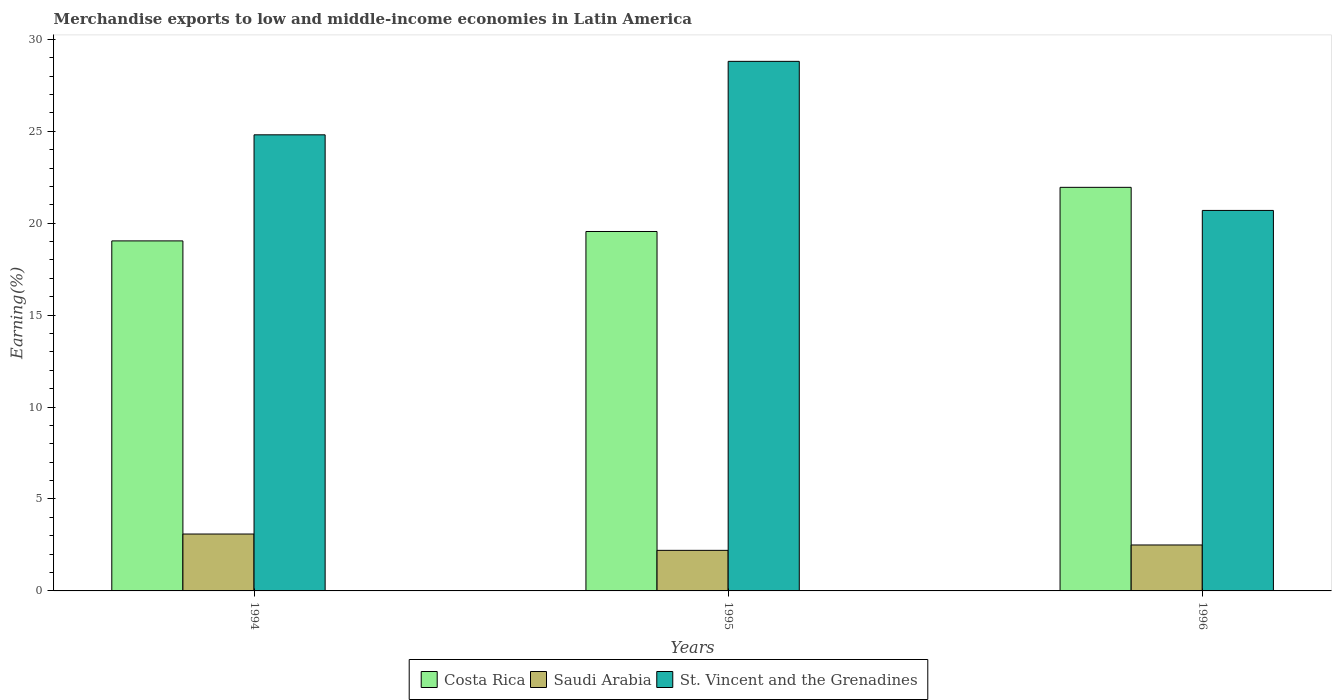How many different coloured bars are there?
Offer a terse response. 3. How many groups of bars are there?
Your answer should be very brief. 3. Are the number of bars on each tick of the X-axis equal?
Make the answer very short. Yes. How many bars are there on the 3rd tick from the left?
Your response must be concise. 3. How many bars are there on the 2nd tick from the right?
Provide a succinct answer. 3. What is the label of the 1st group of bars from the left?
Ensure brevity in your answer.  1994. What is the percentage of amount earned from merchandise exports in Saudi Arabia in 1994?
Offer a terse response. 3.09. Across all years, what is the maximum percentage of amount earned from merchandise exports in Costa Rica?
Offer a terse response. 21.95. Across all years, what is the minimum percentage of amount earned from merchandise exports in Saudi Arabia?
Provide a short and direct response. 2.21. In which year was the percentage of amount earned from merchandise exports in St. Vincent and the Grenadines maximum?
Provide a short and direct response. 1995. What is the total percentage of amount earned from merchandise exports in St. Vincent and the Grenadines in the graph?
Ensure brevity in your answer.  74.3. What is the difference between the percentage of amount earned from merchandise exports in St. Vincent and the Grenadines in 1995 and that in 1996?
Your answer should be compact. 8.11. What is the difference between the percentage of amount earned from merchandise exports in St. Vincent and the Grenadines in 1996 and the percentage of amount earned from merchandise exports in Costa Rica in 1995?
Make the answer very short. 1.15. What is the average percentage of amount earned from merchandise exports in Costa Rica per year?
Offer a very short reply. 20.18. In the year 1996, what is the difference between the percentage of amount earned from merchandise exports in Costa Rica and percentage of amount earned from merchandise exports in Saudi Arabia?
Ensure brevity in your answer.  19.45. In how many years, is the percentage of amount earned from merchandise exports in Saudi Arabia greater than 18 %?
Offer a very short reply. 0. What is the ratio of the percentage of amount earned from merchandise exports in Saudi Arabia in 1994 to that in 1996?
Offer a terse response. 1.24. Is the difference between the percentage of amount earned from merchandise exports in Costa Rica in 1995 and 1996 greater than the difference between the percentage of amount earned from merchandise exports in Saudi Arabia in 1995 and 1996?
Give a very brief answer. No. What is the difference between the highest and the second highest percentage of amount earned from merchandise exports in St. Vincent and the Grenadines?
Your response must be concise. 4. What is the difference between the highest and the lowest percentage of amount earned from merchandise exports in Costa Rica?
Provide a short and direct response. 2.91. Is the sum of the percentage of amount earned from merchandise exports in Saudi Arabia in 1994 and 1996 greater than the maximum percentage of amount earned from merchandise exports in Costa Rica across all years?
Make the answer very short. No. What does the 1st bar from the left in 1994 represents?
Provide a short and direct response. Costa Rica. Does the graph contain grids?
Provide a succinct answer. No. Where does the legend appear in the graph?
Your response must be concise. Bottom center. How many legend labels are there?
Your response must be concise. 3. How are the legend labels stacked?
Ensure brevity in your answer.  Horizontal. What is the title of the graph?
Your answer should be compact. Merchandise exports to low and middle-income economies in Latin America. What is the label or title of the X-axis?
Your answer should be very brief. Years. What is the label or title of the Y-axis?
Keep it short and to the point. Earning(%). What is the Earning(%) of Costa Rica in 1994?
Your answer should be compact. 19.04. What is the Earning(%) in Saudi Arabia in 1994?
Your answer should be very brief. 3.09. What is the Earning(%) of St. Vincent and the Grenadines in 1994?
Provide a short and direct response. 24.81. What is the Earning(%) in Costa Rica in 1995?
Your response must be concise. 19.55. What is the Earning(%) of Saudi Arabia in 1995?
Your response must be concise. 2.21. What is the Earning(%) in St. Vincent and the Grenadines in 1995?
Make the answer very short. 28.8. What is the Earning(%) in Costa Rica in 1996?
Provide a succinct answer. 21.95. What is the Earning(%) of Saudi Arabia in 1996?
Ensure brevity in your answer.  2.5. What is the Earning(%) of St. Vincent and the Grenadines in 1996?
Provide a succinct answer. 20.69. Across all years, what is the maximum Earning(%) of Costa Rica?
Provide a succinct answer. 21.95. Across all years, what is the maximum Earning(%) in Saudi Arabia?
Provide a short and direct response. 3.09. Across all years, what is the maximum Earning(%) of St. Vincent and the Grenadines?
Make the answer very short. 28.8. Across all years, what is the minimum Earning(%) of Costa Rica?
Offer a very short reply. 19.04. Across all years, what is the minimum Earning(%) in Saudi Arabia?
Your response must be concise. 2.21. Across all years, what is the minimum Earning(%) in St. Vincent and the Grenadines?
Provide a short and direct response. 20.69. What is the total Earning(%) of Costa Rica in the graph?
Offer a terse response. 60.54. What is the total Earning(%) of Saudi Arabia in the graph?
Give a very brief answer. 7.8. What is the total Earning(%) in St. Vincent and the Grenadines in the graph?
Ensure brevity in your answer.  74.3. What is the difference between the Earning(%) of Costa Rica in 1994 and that in 1995?
Make the answer very short. -0.51. What is the difference between the Earning(%) of Saudi Arabia in 1994 and that in 1995?
Offer a terse response. 0.89. What is the difference between the Earning(%) of St. Vincent and the Grenadines in 1994 and that in 1995?
Make the answer very short. -4. What is the difference between the Earning(%) of Costa Rica in 1994 and that in 1996?
Provide a short and direct response. -2.91. What is the difference between the Earning(%) of Saudi Arabia in 1994 and that in 1996?
Your response must be concise. 0.6. What is the difference between the Earning(%) in St. Vincent and the Grenadines in 1994 and that in 1996?
Give a very brief answer. 4.11. What is the difference between the Earning(%) of Costa Rica in 1995 and that in 1996?
Your response must be concise. -2.4. What is the difference between the Earning(%) in Saudi Arabia in 1995 and that in 1996?
Keep it short and to the point. -0.29. What is the difference between the Earning(%) of St. Vincent and the Grenadines in 1995 and that in 1996?
Your response must be concise. 8.11. What is the difference between the Earning(%) of Costa Rica in 1994 and the Earning(%) of Saudi Arabia in 1995?
Your answer should be compact. 16.83. What is the difference between the Earning(%) in Costa Rica in 1994 and the Earning(%) in St. Vincent and the Grenadines in 1995?
Ensure brevity in your answer.  -9.76. What is the difference between the Earning(%) of Saudi Arabia in 1994 and the Earning(%) of St. Vincent and the Grenadines in 1995?
Your answer should be very brief. -25.71. What is the difference between the Earning(%) in Costa Rica in 1994 and the Earning(%) in Saudi Arabia in 1996?
Offer a very short reply. 16.54. What is the difference between the Earning(%) in Costa Rica in 1994 and the Earning(%) in St. Vincent and the Grenadines in 1996?
Keep it short and to the point. -1.66. What is the difference between the Earning(%) in Saudi Arabia in 1994 and the Earning(%) in St. Vincent and the Grenadines in 1996?
Offer a very short reply. -17.6. What is the difference between the Earning(%) in Costa Rica in 1995 and the Earning(%) in Saudi Arabia in 1996?
Ensure brevity in your answer.  17.05. What is the difference between the Earning(%) of Costa Rica in 1995 and the Earning(%) of St. Vincent and the Grenadines in 1996?
Give a very brief answer. -1.15. What is the difference between the Earning(%) of Saudi Arabia in 1995 and the Earning(%) of St. Vincent and the Grenadines in 1996?
Your response must be concise. -18.49. What is the average Earning(%) in Costa Rica per year?
Offer a very short reply. 20.18. What is the average Earning(%) in Saudi Arabia per year?
Keep it short and to the point. 2.6. What is the average Earning(%) of St. Vincent and the Grenadines per year?
Keep it short and to the point. 24.77. In the year 1994, what is the difference between the Earning(%) in Costa Rica and Earning(%) in Saudi Arabia?
Give a very brief answer. 15.94. In the year 1994, what is the difference between the Earning(%) in Costa Rica and Earning(%) in St. Vincent and the Grenadines?
Offer a very short reply. -5.77. In the year 1994, what is the difference between the Earning(%) of Saudi Arabia and Earning(%) of St. Vincent and the Grenadines?
Your response must be concise. -21.71. In the year 1995, what is the difference between the Earning(%) in Costa Rica and Earning(%) in Saudi Arabia?
Ensure brevity in your answer.  17.34. In the year 1995, what is the difference between the Earning(%) of Costa Rica and Earning(%) of St. Vincent and the Grenadines?
Provide a short and direct response. -9.25. In the year 1995, what is the difference between the Earning(%) of Saudi Arabia and Earning(%) of St. Vincent and the Grenadines?
Ensure brevity in your answer.  -26.6. In the year 1996, what is the difference between the Earning(%) of Costa Rica and Earning(%) of Saudi Arabia?
Your response must be concise. 19.45. In the year 1996, what is the difference between the Earning(%) in Costa Rica and Earning(%) in St. Vincent and the Grenadines?
Your answer should be very brief. 1.26. In the year 1996, what is the difference between the Earning(%) of Saudi Arabia and Earning(%) of St. Vincent and the Grenadines?
Offer a very short reply. -18.2. What is the ratio of the Earning(%) of Costa Rica in 1994 to that in 1995?
Provide a short and direct response. 0.97. What is the ratio of the Earning(%) of Saudi Arabia in 1994 to that in 1995?
Ensure brevity in your answer.  1.4. What is the ratio of the Earning(%) of St. Vincent and the Grenadines in 1994 to that in 1995?
Make the answer very short. 0.86. What is the ratio of the Earning(%) of Costa Rica in 1994 to that in 1996?
Make the answer very short. 0.87. What is the ratio of the Earning(%) in Saudi Arabia in 1994 to that in 1996?
Provide a short and direct response. 1.24. What is the ratio of the Earning(%) in St. Vincent and the Grenadines in 1994 to that in 1996?
Your answer should be compact. 1.2. What is the ratio of the Earning(%) in Costa Rica in 1995 to that in 1996?
Provide a succinct answer. 0.89. What is the ratio of the Earning(%) of Saudi Arabia in 1995 to that in 1996?
Your answer should be compact. 0.88. What is the ratio of the Earning(%) of St. Vincent and the Grenadines in 1995 to that in 1996?
Your response must be concise. 1.39. What is the difference between the highest and the second highest Earning(%) in Costa Rica?
Your answer should be compact. 2.4. What is the difference between the highest and the second highest Earning(%) of Saudi Arabia?
Provide a short and direct response. 0.6. What is the difference between the highest and the second highest Earning(%) in St. Vincent and the Grenadines?
Provide a short and direct response. 4. What is the difference between the highest and the lowest Earning(%) of Costa Rica?
Provide a short and direct response. 2.91. What is the difference between the highest and the lowest Earning(%) in Saudi Arabia?
Give a very brief answer. 0.89. What is the difference between the highest and the lowest Earning(%) of St. Vincent and the Grenadines?
Your response must be concise. 8.11. 